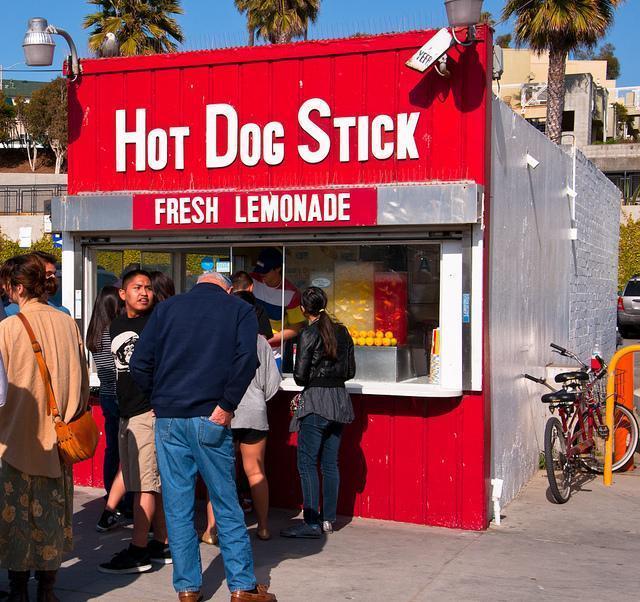How many lights are attached to the outside of the building?
Give a very brief answer. 2. How many times does the word "dogs" appear in the image?
Give a very brief answer. 0. How many people are there?
Give a very brief answer. 7. How many bears are in this picture?
Give a very brief answer. 0. 